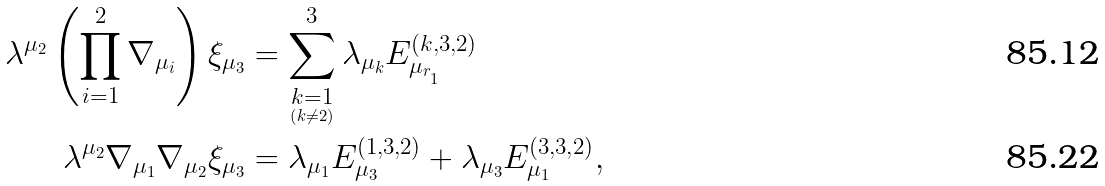Convert formula to latex. <formula><loc_0><loc_0><loc_500><loc_500>\lambda ^ { \mu _ { 2 } } \left ( \prod _ { i = 1 } ^ { 2 } \nabla _ { \mu _ { i } } \right ) \xi _ { \mu _ { 3 } } & = \sum _ { \underset { \left ( k \ne 2 \right ) } { k = 1 } } ^ { 3 } \lambda _ { \mu _ { k } } E _ { \mu _ { r _ { _ { 1 } } } } ^ { \left ( k , 3 , 2 \right ) } \\ \lambda ^ { \mu _ { 2 } } \nabla _ { \mu _ { 1 } } \nabla _ { \mu _ { 2 } } \xi _ { \mu _ { 3 } } & = \lambda _ { \mu _ { 1 } } E _ { \mu _ { 3 } } ^ { \left ( 1 , 3 , 2 \right ) } + \lambda _ { \mu _ { 3 } } E _ { \mu _ { 1 } } ^ { \left ( 3 , 3 , 2 \right ) } ,</formula> 